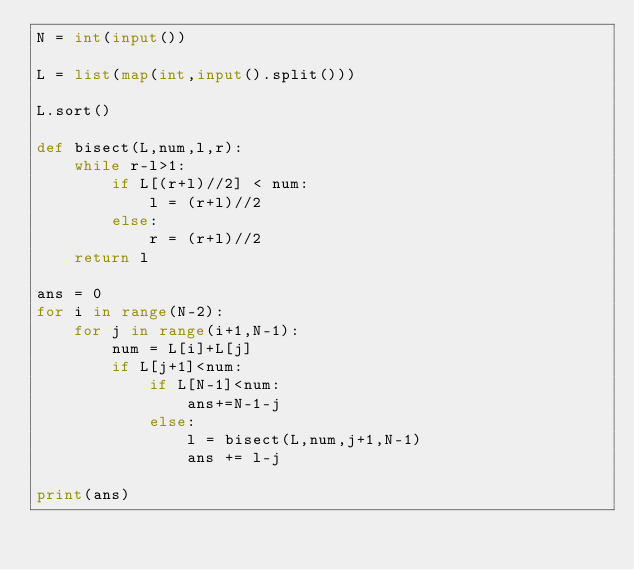Convert code to text. <code><loc_0><loc_0><loc_500><loc_500><_Python_>N = int(input())

L = list(map(int,input().split()))

L.sort()

def bisect(L,num,l,r):
    while r-l>1:
        if L[(r+l)//2] < num:
            l = (r+l)//2
        else:
            r = (r+l)//2
    return l

ans = 0
for i in range(N-2):
    for j in range(i+1,N-1):
        num = L[i]+L[j]
        if L[j+1]<num:
            if L[N-1]<num:
                ans+=N-1-j
            else:
                l = bisect(L,num,j+1,N-1)
                ans += l-j

print(ans)</code> 